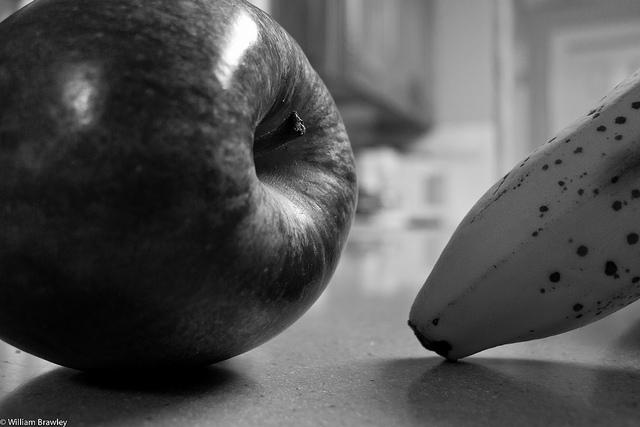What fruits are visible?
Write a very short answer. Apple and banana. What color is the apple?
Short answer required. Red. Is the apple half-eaten?
Keep it brief. No. 